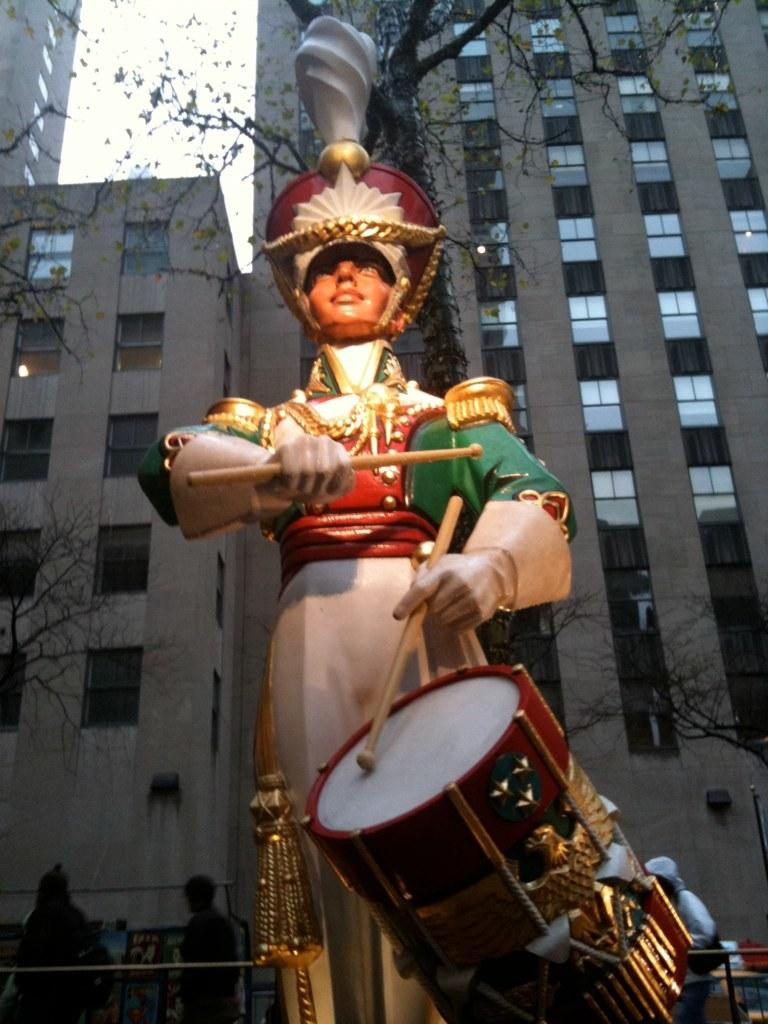What is the main subject in the image? There is a statue in the image. What can be seen in the background of the image? There are people, trees, and buildings in the background of the image. What type of form can be seen in the statue's hearing in the image? The statue does not have hearing, as it is an inanimate object. 